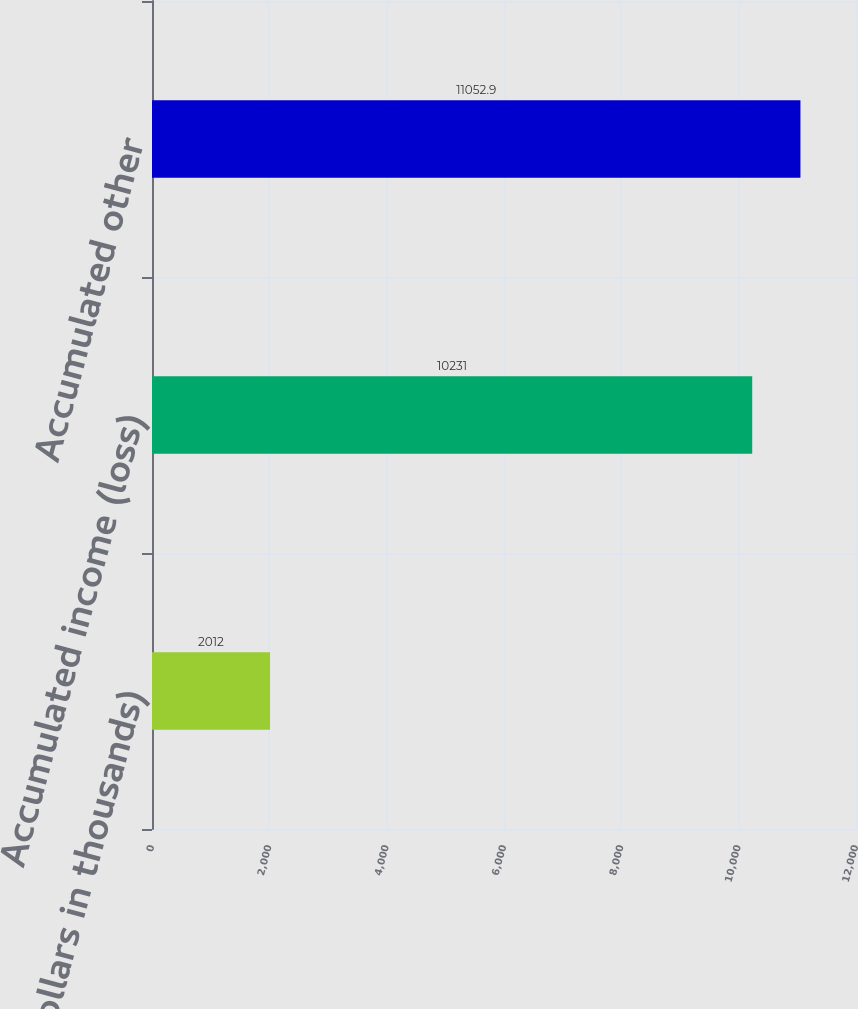Convert chart. <chart><loc_0><loc_0><loc_500><loc_500><bar_chart><fcel>(Dollars in thousands)<fcel>Accumulated income (loss)<fcel>Accumulated other<nl><fcel>2012<fcel>10231<fcel>11052.9<nl></chart> 